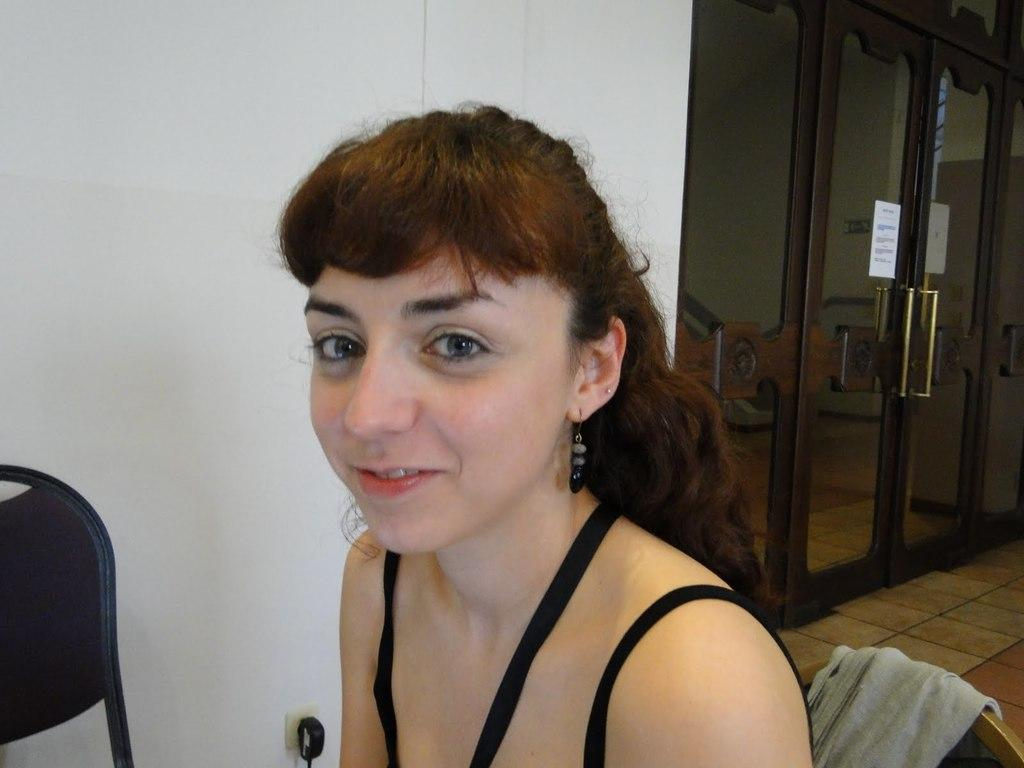What is the color of the wall in the image? There is a white color wall in the image. What can be seen on the wall in the image? There is a door in the image. What is the woman in the image doing? The woman is sitting on a chair in the image. Is the woman in the image a spy? There is no information in the image to suggest that the woman is a spy. Is the room in the image a prison cell? There is no information in the image to suggest that the room is a prison cell. 